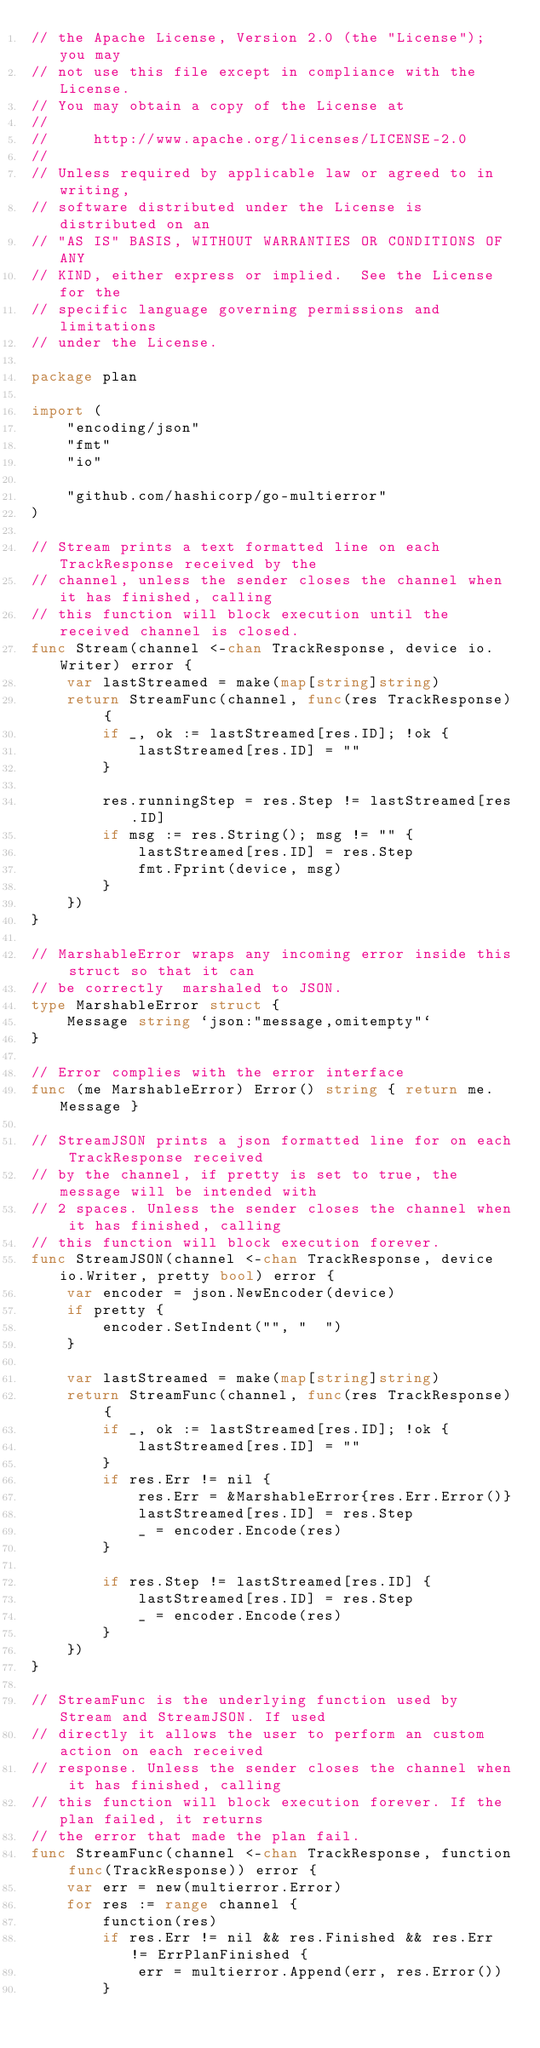Convert code to text. <code><loc_0><loc_0><loc_500><loc_500><_Go_>// the Apache License, Version 2.0 (the "License"); you may
// not use this file except in compliance with the License.
// You may obtain a copy of the License at
//
//     http://www.apache.org/licenses/LICENSE-2.0
//
// Unless required by applicable law or agreed to in writing,
// software distributed under the License is distributed on an
// "AS IS" BASIS, WITHOUT WARRANTIES OR CONDITIONS OF ANY
// KIND, either express or implied.  See the License for the
// specific language governing permissions and limitations
// under the License.

package plan

import (
	"encoding/json"
	"fmt"
	"io"

	"github.com/hashicorp/go-multierror"
)

// Stream prints a text formatted line on each TrackResponse received by the
// channel, unless the sender closes the channel when it has finished, calling
// this function will block execution until the received channel is closed.
func Stream(channel <-chan TrackResponse, device io.Writer) error {
	var lastStreamed = make(map[string]string)
	return StreamFunc(channel, func(res TrackResponse) {
		if _, ok := lastStreamed[res.ID]; !ok {
			lastStreamed[res.ID] = ""
		}

		res.runningStep = res.Step != lastStreamed[res.ID]
		if msg := res.String(); msg != "" {
			lastStreamed[res.ID] = res.Step
			fmt.Fprint(device, msg)
		}
	})
}

// MarshableError wraps any incoming error inside this struct so that it can
// be correctly  marshaled to JSON.
type MarshableError struct {
	Message string `json:"message,omitempty"`
}

// Error complies with the error interface
func (me MarshableError) Error() string { return me.Message }

// StreamJSON prints a json formatted line for on each TrackResponse received
// by the channel, if pretty is set to true, the message will be intended with
// 2 spaces. Unless the sender closes the channel when it has finished, calling
// this function will block execution forever.
func StreamJSON(channel <-chan TrackResponse, device io.Writer, pretty bool) error {
	var encoder = json.NewEncoder(device)
	if pretty {
		encoder.SetIndent("", "  ")
	}

	var lastStreamed = make(map[string]string)
	return StreamFunc(channel, func(res TrackResponse) {
		if _, ok := lastStreamed[res.ID]; !ok {
			lastStreamed[res.ID] = ""
		}
		if res.Err != nil {
			res.Err = &MarshableError{res.Err.Error()}
			lastStreamed[res.ID] = res.Step
			_ = encoder.Encode(res)
		}

		if res.Step != lastStreamed[res.ID] {
			lastStreamed[res.ID] = res.Step
			_ = encoder.Encode(res)
		}
	})
}

// StreamFunc is the underlying function used by Stream and StreamJSON. If used
// directly it allows the user to perform an custom action on each received
// response. Unless the sender closes the channel when it has finished, calling
// this function will block execution forever. If the plan failed, it returns
// the error that made the plan fail.
func StreamFunc(channel <-chan TrackResponse, function func(TrackResponse)) error {
	var err = new(multierror.Error)
	for res := range channel {
		function(res)
		if res.Err != nil && res.Finished && res.Err != ErrPlanFinished {
			err = multierror.Append(err, res.Error())
		}</code> 